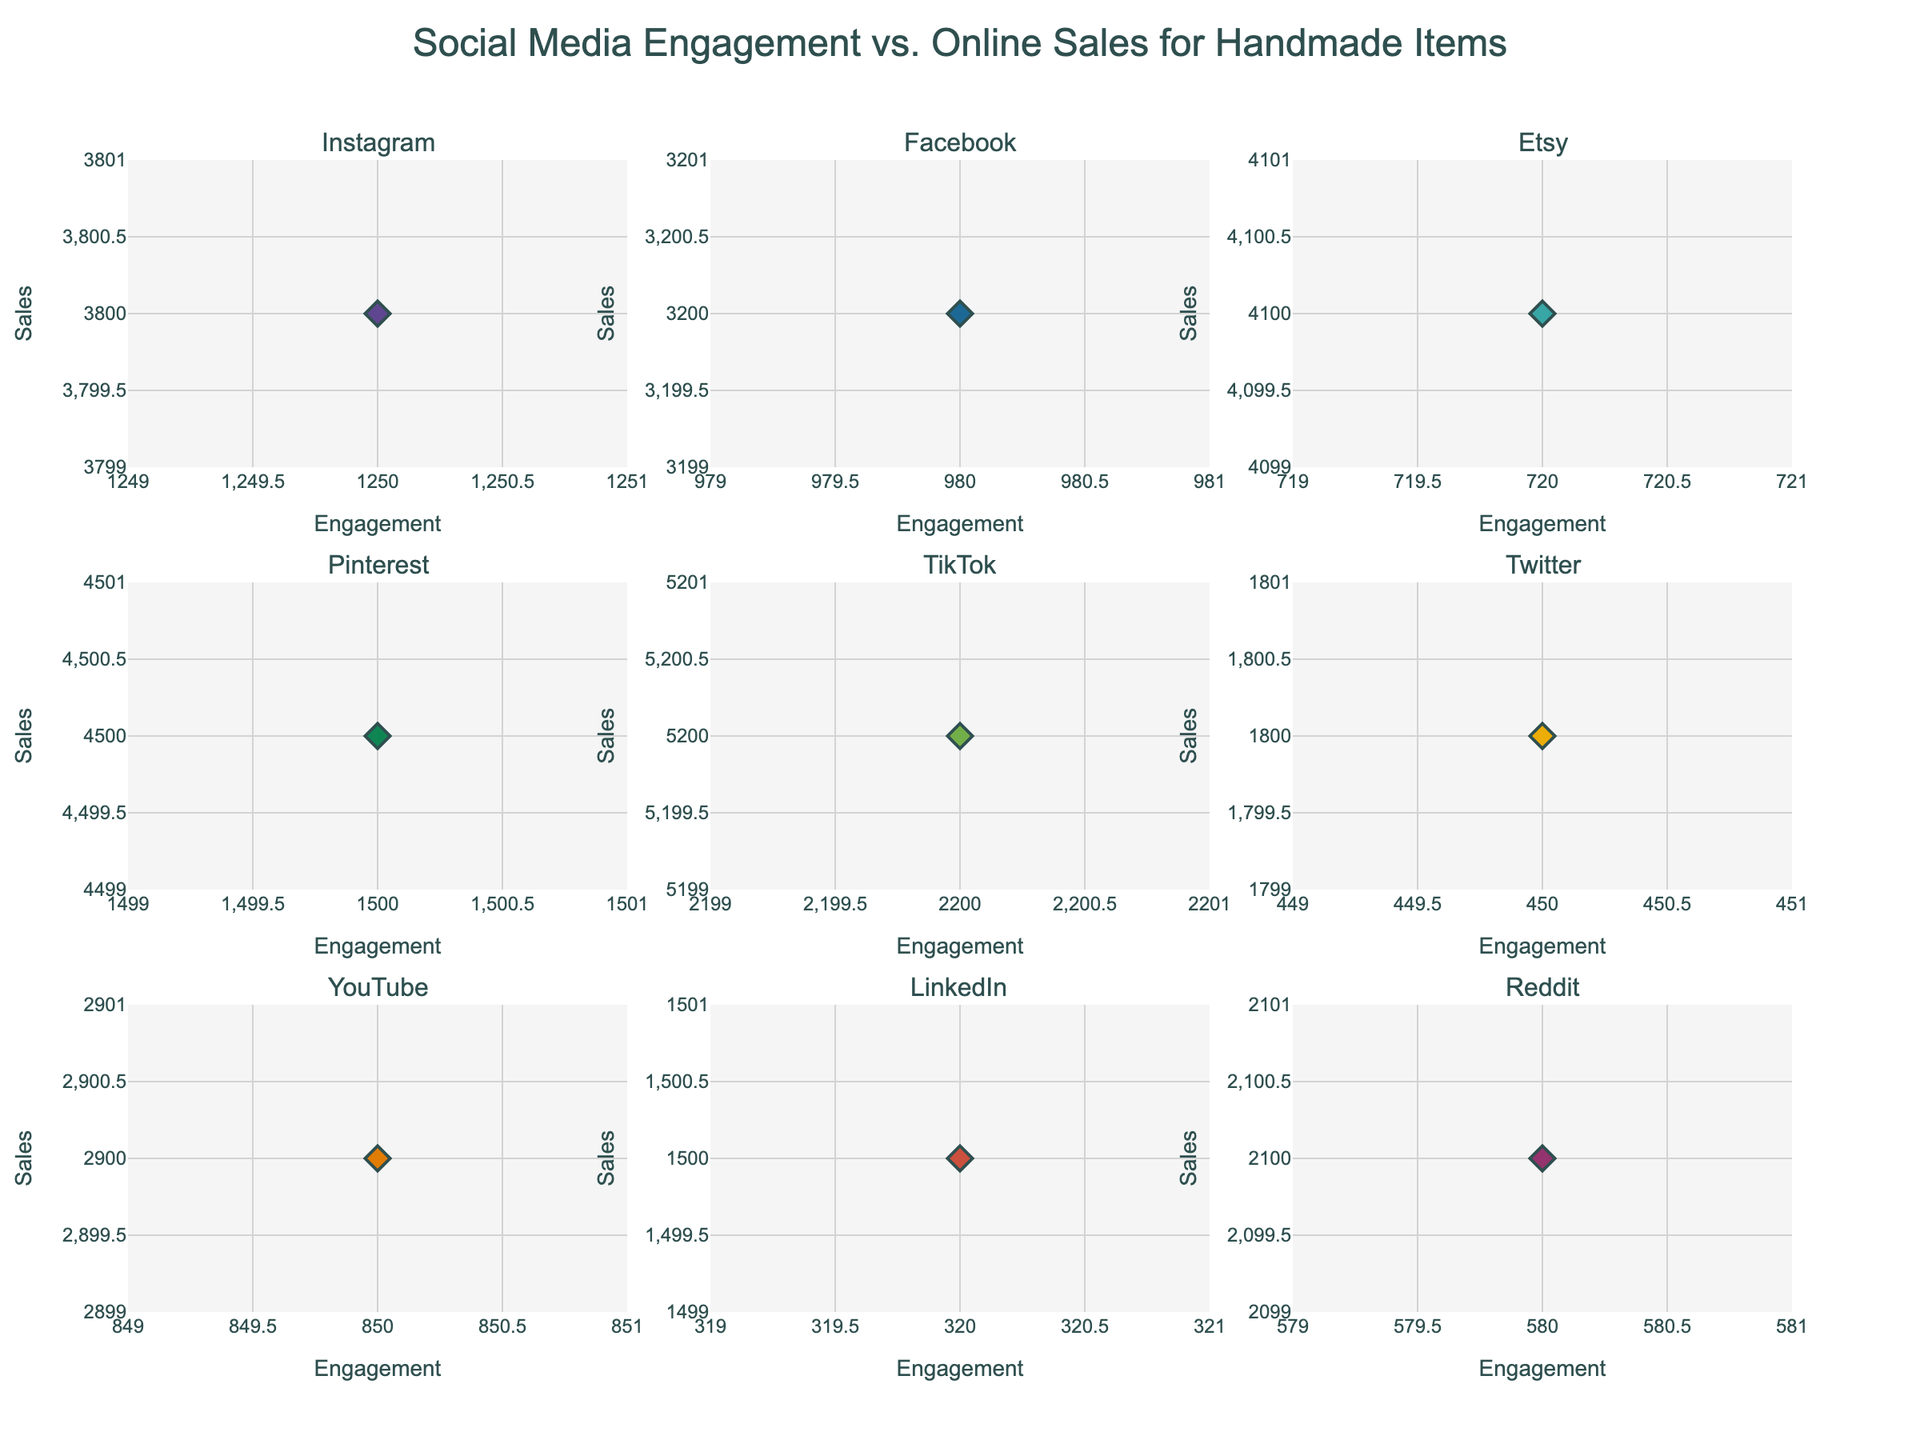What does the title of the figure indicate? The title of the figure is "Social Media Engagement vs. Online Sales for Handmade Items," indicating that the data shows the relationship between engagement on various social media platforms and the sales of handmade items.
Answer: Relationship between social media engagement and online sales for handmade items What is the x-axis labeled as in each subplot? Each subplot's x-axis is labeled as "Engagement," showing the level of engagement on social media platforms.
Answer: Engagement How many platforms are shown in the subplots? There are 9 platforms shown in the subplots as indicated by the individual titles of each subplot.
Answer: 9 Which platform has the highest engagement value in its subplot? In the subplot, TikTok has the highest engagement value of 2200.
Answer: TikTok What are the range of engagement values for Instagram and Etsy? For Instagram, the engagement value is 1250, and for Etsy, it is 720.
Answer: 1250 for Instagram, 720 for Etsy Which platform shows the highest sales and what is the corresponding engagement value? TikTok shows the highest sales with a sales value of 5200 and an engagement value of 2200.
Answer: TikTok with 2200 engagement and 5200 sales What is the overall trend between engagement and sales visible in the plots? The overall trend indicates a positive correlation; as engagement increases, sales tend to increase as well.
Answer: Positive correlation How does Pinterest's engagement compare to Snapchat's? Pinterest has a higher engagement value of 1500 compared to Snapchat's engagement value of 680.
Answer: Pinterest has higher engagement Which platforms have engagement values below 500 and what are their sales values? The platforms with engagement values below 500 are LinkedIn (320 engagement with 1500 sales), Tumblr (290 engagement with 1200 sales), WeChat (180 engagement with 900 sales), Vimeo (220 engagement with 1100 sales), and Flickr (150 engagement with 800 sales).
Answer: LinkedIn: 320 engagement and 1500 sales, Tumblr: 290 engagement and 1200 sales, WeChat: 180 engagement and 900 sales, Vimeo: 220 engagement and 1100 sales, Flickr: 150 engagement and 800 sales On which platform does an engagement value of around 700 lead to relatively higher sales compared to others? For Etsy, an engagement value of 720 leads to relatively higher sales of 4100 compared to platforms with similar engagement levels.
Answer: Etsy 